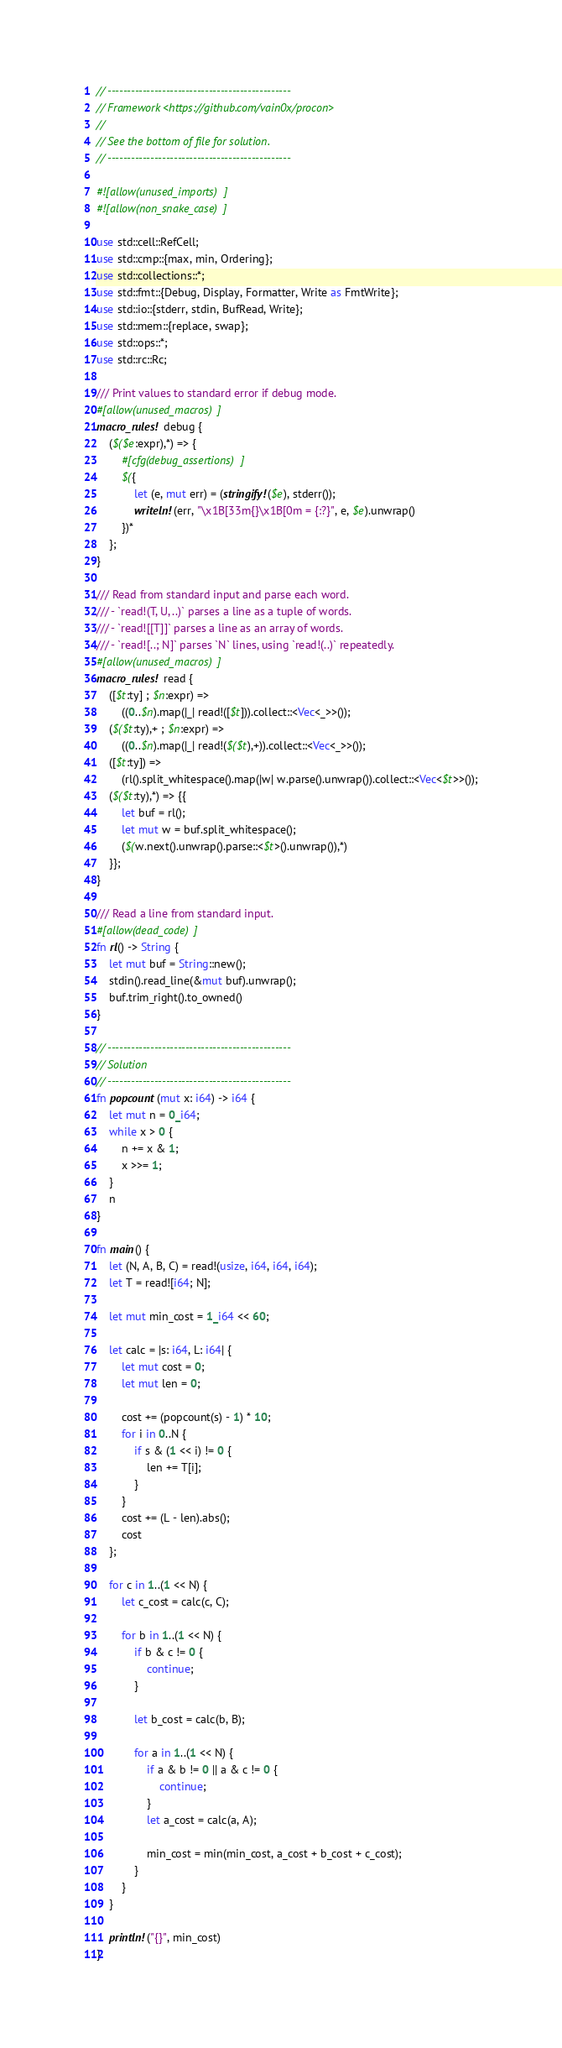<code> <loc_0><loc_0><loc_500><loc_500><_Rust_>// -----------------------------------------------
// Framework <https://github.com/vain0x/procon>
//
// See the bottom of file for solution.
// -----------------------------------------------

#![allow(unused_imports)]
#![allow(non_snake_case)]

use std::cell::RefCell;
use std::cmp::{max, min, Ordering};
use std::collections::*;
use std::fmt::{Debug, Display, Formatter, Write as FmtWrite};
use std::io::{stderr, stdin, BufRead, Write};
use std::mem::{replace, swap};
use std::ops::*;
use std::rc::Rc;

/// Print values to standard error if debug mode.
#[allow(unused_macros)]
macro_rules! debug {
    ($($e:expr),*) => {
        #[cfg(debug_assertions)]
        $({
            let (e, mut err) = (stringify!($e), stderr());
            writeln!(err, "\x1B[33m{}\x1B[0m = {:?}", e, $e).unwrap()
        })*
    };
}

/// Read from standard input and parse each word.
/// - `read!(T, U, ..)` parses a line as a tuple of words.
/// - `read![[T]]` parses a line as an array of words.
/// - `read![..; N]` parses `N` lines, using `read!(..)` repeatedly.
#[allow(unused_macros)]
macro_rules! read {
    ([$t:ty] ; $n:expr) =>
        ((0..$n).map(|_| read!([$t])).collect::<Vec<_>>());
    ($($t:ty),+ ; $n:expr) =>
        ((0..$n).map(|_| read!($($t),+)).collect::<Vec<_>>());
    ([$t:ty]) =>
        (rl().split_whitespace().map(|w| w.parse().unwrap()).collect::<Vec<$t>>());
    ($($t:ty),*) => {{
        let buf = rl();
        let mut w = buf.split_whitespace();
        ($(w.next().unwrap().parse::<$t>().unwrap()),*)
    }};
}

/// Read a line from standard input.
#[allow(dead_code)]
fn rl() -> String {
    let mut buf = String::new();
    stdin().read_line(&mut buf).unwrap();
    buf.trim_right().to_owned()
}

// -----------------------------------------------
// Solution
// -----------------------------------------------
fn popcount(mut x: i64) -> i64 {
    let mut n = 0_i64;
    while x > 0 {
        n += x & 1;
        x >>= 1;
    }
    n
}

fn main() {
    let (N, A, B, C) = read!(usize, i64, i64, i64);
    let T = read![i64; N];

    let mut min_cost = 1_i64 << 60;

    let calc = |s: i64, L: i64| {
        let mut cost = 0;
        let mut len = 0;

        cost += (popcount(s) - 1) * 10;
        for i in 0..N {
            if s & (1 << i) != 0 {
                len += T[i];
            }
        }
        cost += (L - len).abs();
        cost
    };

    for c in 1..(1 << N) {
        let c_cost = calc(c, C);

        for b in 1..(1 << N) {
            if b & c != 0 {
                continue;
            }

            let b_cost = calc(b, B);

            for a in 1..(1 << N) {
                if a & b != 0 || a & c != 0 {
                    continue;
                }
                let a_cost = calc(a, A);

                min_cost = min(min_cost, a_cost + b_cost + c_cost);
            }
        }
    }

    println!("{}", min_cost)
}
</code> 